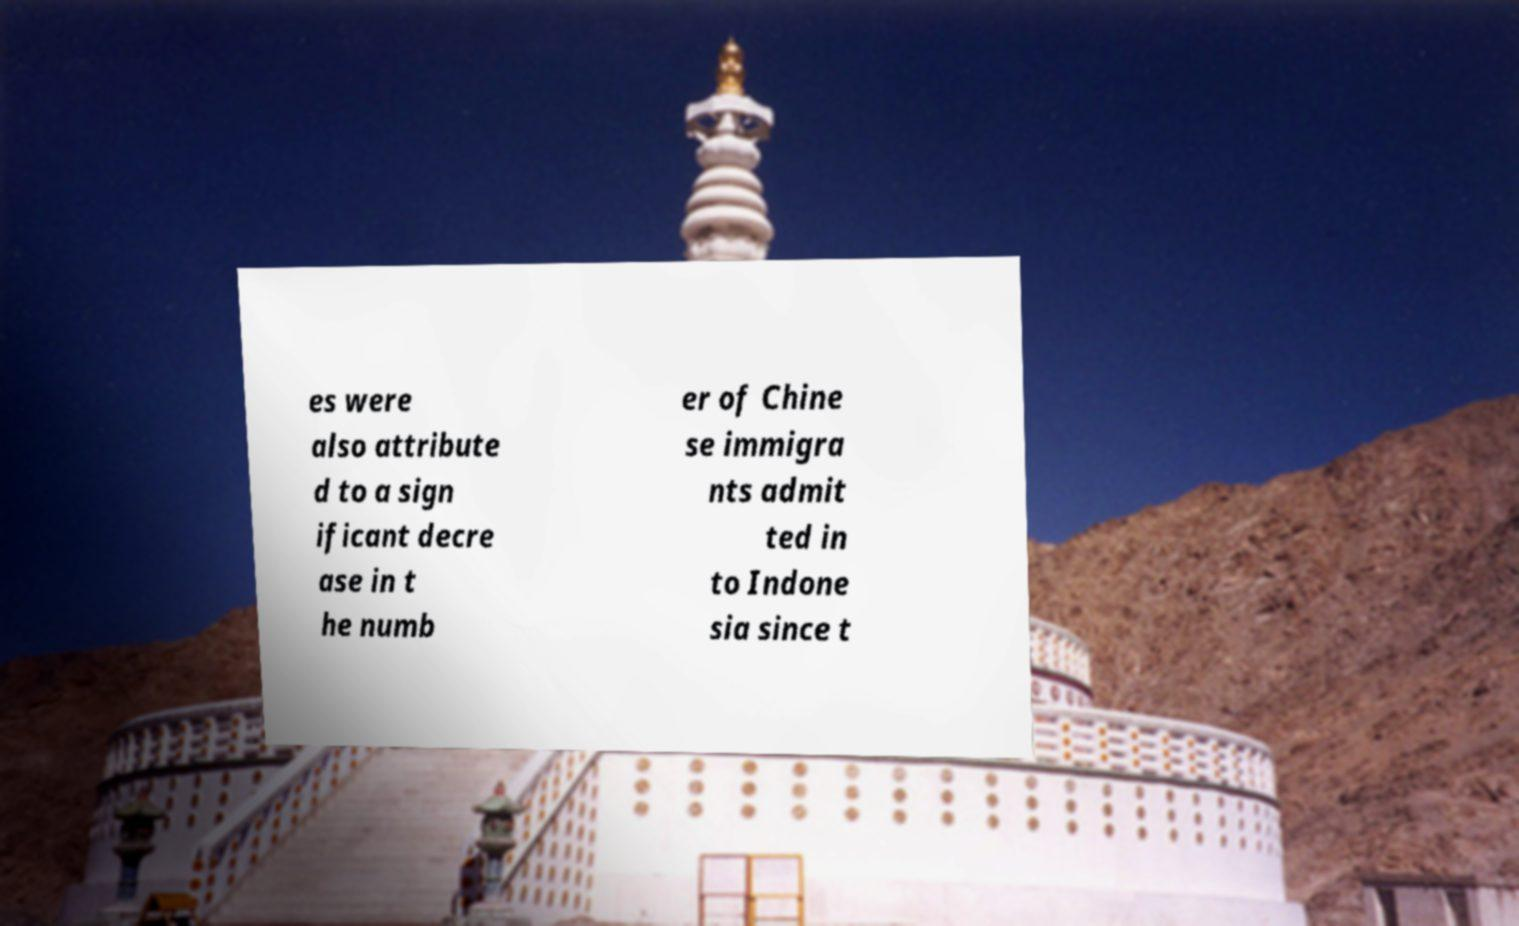Can you accurately transcribe the text from the provided image for me? es were also attribute d to a sign ificant decre ase in t he numb er of Chine se immigra nts admit ted in to Indone sia since t 